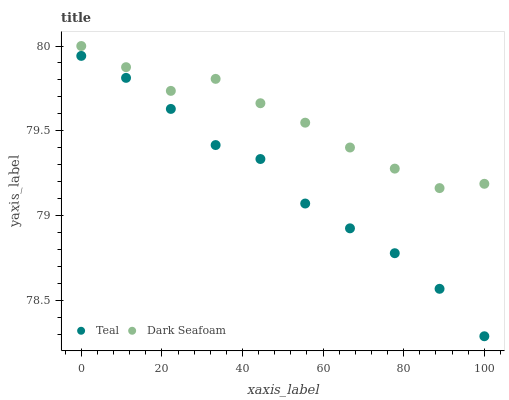Does Teal have the minimum area under the curve?
Answer yes or no. Yes. Does Dark Seafoam have the maximum area under the curve?
Answer yes or no. Yes. Does Teal have the maximum area under the curve?
Answer yes or no. No. Is Teal the smoothest?
Answer yes or no. Yes. Is Dark Seafoam the roughest?
Answer yes or no. Yes. Is Teal the roughest?
Answer yes or no. No. Does Teal have the lowest value?
Answer yes or no. Yes. Does Dark Seafoam have the highest value?
Answer yes or no. Yes. Does Teal have the highest value?
Answer yes or no. No. Is Teal less than Dark Seafoam?
Answer yes or no. Yes. Is Dark Seafoam greater than Teal?
Answer yes or no. Yes. Does Teal intersect Dark Seafoam?
Answer yes or no. No. 